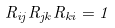Convert formula to latex. <formula><loc_0><loc_0><loc_500><loc_500>R _ { i j } R _ { j k } R _ { k i } = 1</formula> 